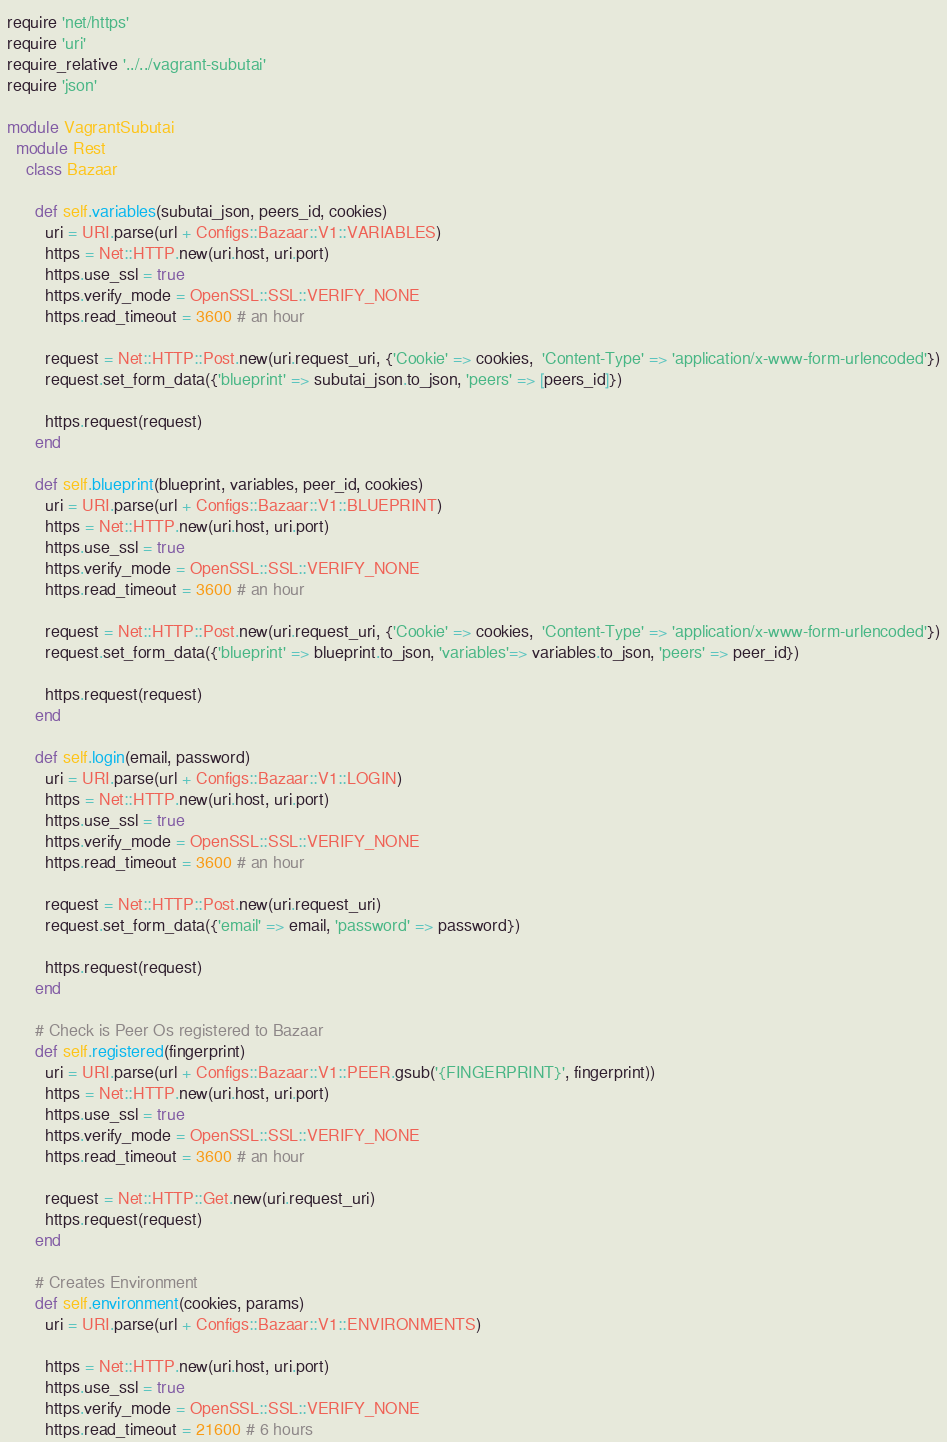Convert code to text. <code><loc_0><loc_0><loc_500><loc_500><_Ruby_>require 'net/https'
require 'uri'
require_relative '../../vagrant-subutai'
require 'json'

module VagrantSubutai
  module Rest
    class Bazaar

      def self.variables(subutai_json, peers_id, cookies)
        uri = URI.parse(url + Configs::Bazaar::V1::VARIABLES)
        https = Net::HTTP.new(uri.host, uri.port)
        https.use_ssl = true
        https.verify_mode = OpenSSL::SSL::VERIFY_NONE
        https.read_timeout = 3600 # an hour

        request = Net::HTTP::Post.new(uri.request_uri, {'Cookie' => cookies,  'Content-Type' => 'application/x-www-form-urlencoded'})
        request.set_form_data({'blueprint' => subutai_json.to_json, 'peers' => [peers_id]})

        https.request(request)
      end

      def self.blueprint(blueprint, variables, peer_id, cookies)
        uri = URI.parse(url + Configs::Bazaar::V1::BLUEPRINT)
        https = Net::HTTP.new(uri.host, uri.port)
        https.use_ssl = true
        https.verify_mode = OpenSSL::SSL::VERIFY_NONE
        https.read_timeout = 3600 # an hour

        request = Net::HTTP::Post.new(uri.request_uri, {'Cookie' => cookies,  'Content-Type' => 'application/x-www-form-urlencoded'})
        request.set_form_data({'blueprint' => blueprint.to_json, 'variables'=> variables.to_json, 'peers' => peer_id})

        https.request(request)
      end

      def self.login(email, password)
        uri = URI.parse(url + Configs::Bazaar::V1::LOGIN)
        https = Net::HTTP.new(uri.host, uri.port)
        https.use_ssl = true
        https.verify_mode = OpenSSL::SSL::VERIFY_NONE
        https.read_timeout = 3600 # an hour

        request = Net::HTTP::Post.new(uri.request_uri)
        request.set_form_data({'email' => email, 'password' => password})

        https.request(request)
      end

      # Check is Peer Os registered to Bazaar
      def self.registered(fingerprint)
        uri = URI.parse(url + Configs::Bazaar::V1::PEER.gsub('{FINGERPRINT}', fingerprint))
        https = Net::HTTP.new(uri.host, uri.port)
        https.use_ssl = true
        https.verify_mode = OpenSSL::SSL::VERIFY_NONE
        https.read_timeout = 3600 # an hour

        request = Net::HTTP::Get.new(uri.request_uri)
        https.request(request)
      end

      # Creates Environment
      def self.environment(cookies, params)
        uri = URI.parse(url + Configs::Bazaar::V1::ENVIRONMENTS)

        https = Net::HTTP.new(uri.host, uri.port)
        https.use_ssl = true
        https.verify_mode = OpenSSL::SSL::VERIFY_NONE
        https.read_timeout = 21600 # 6 hours
</code> 